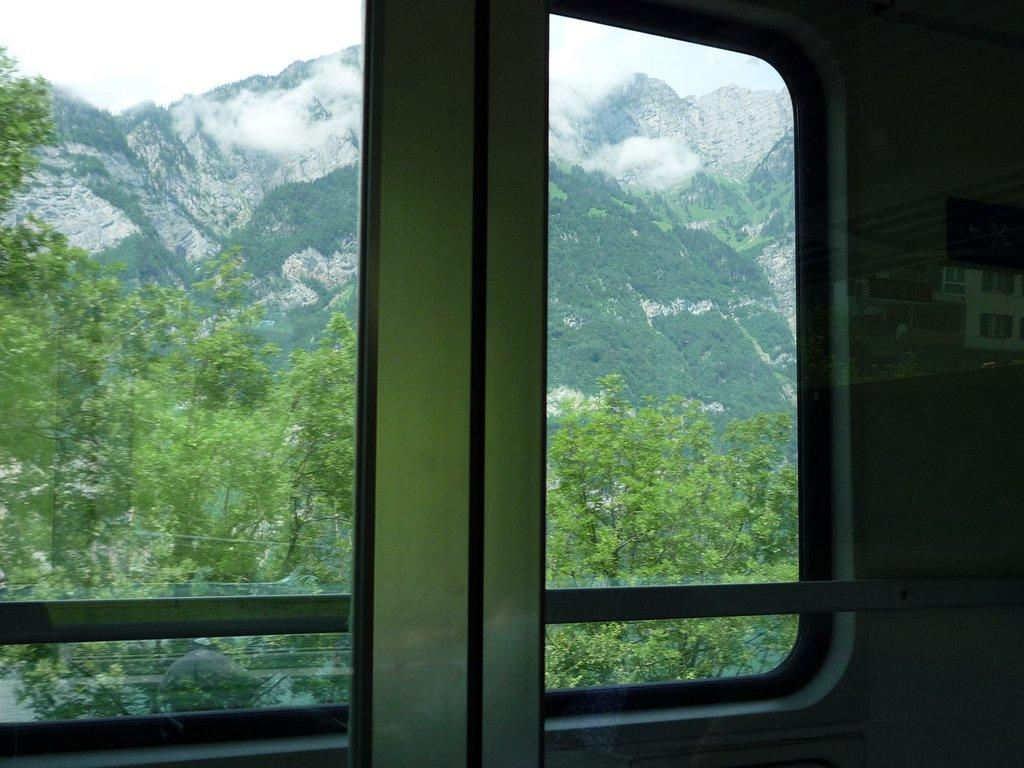What type of surface is being used to view the image? The image is being viewed through a glass surface. What type of natural environment can be seen in the image? There are trees and hills visible in the image. What part of the natural environment is visible in the image? The sky is visible in the image. Can you see a balloon floating in the sky in the image? There is no balloon visible in the sky in the image. Is there a stop sign present in the image? There is no stop sign present in the image. 